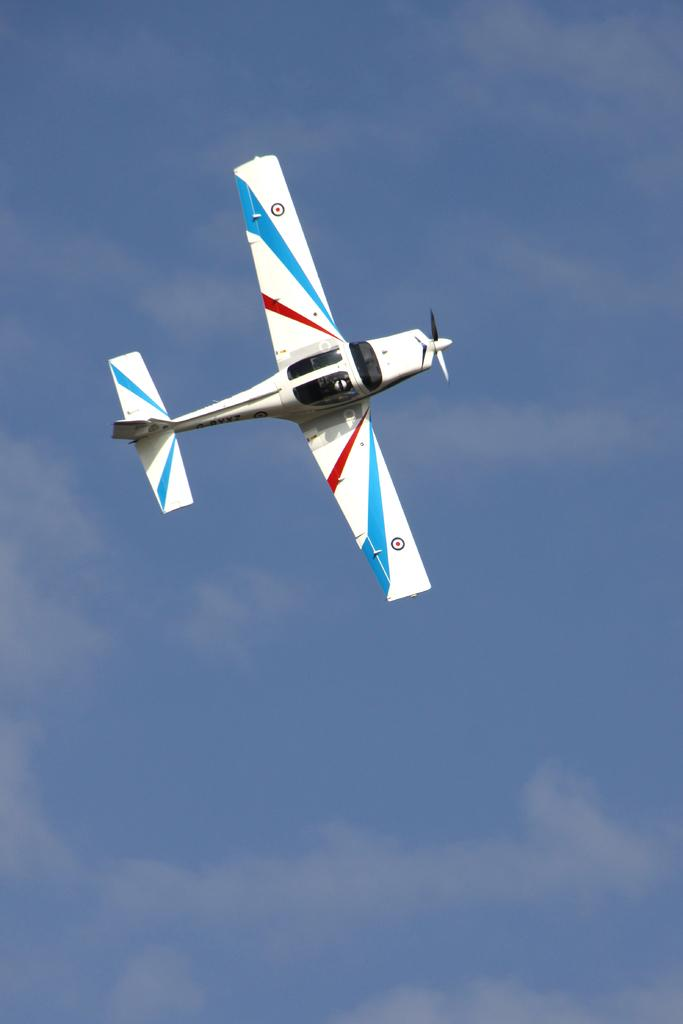What is the main subject of the picture? The main subject of the picture is an aircraft. What can be seen in the background of the image? The sky is visible in the picture. What is the condition of the sky in the image? Clouds are present in the sky. What type of credit can be seen on the aircraft in the image? There is no credit visible on the aircraft in the image. Can you recite a verse from the aircraft's manual in the image? There is no aircraft manual or text present in the image to recite a verse from. 